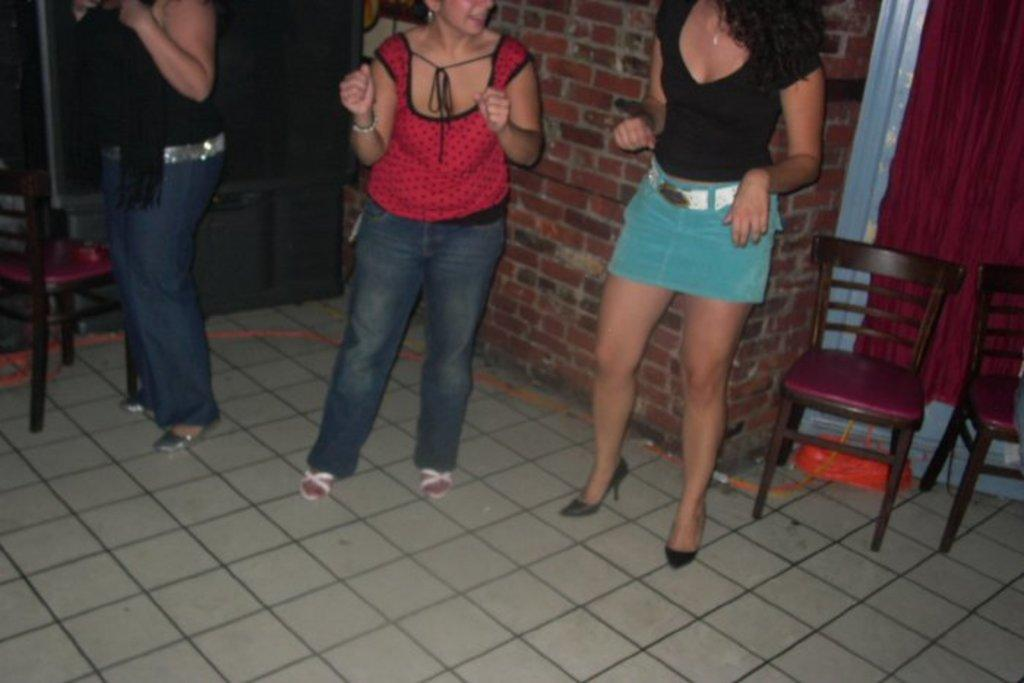How many women are present in the image? There are three women in the image. What are the women doing in the image? The women are standing. What objects are around the women? There are chairs around the women. What can be seen in the background of the image? There is a TV in the background of the image. What color is the lip of the woman on the left? There is no mention of a lip or any specific woman's position in the image, so it cannot be determined. 